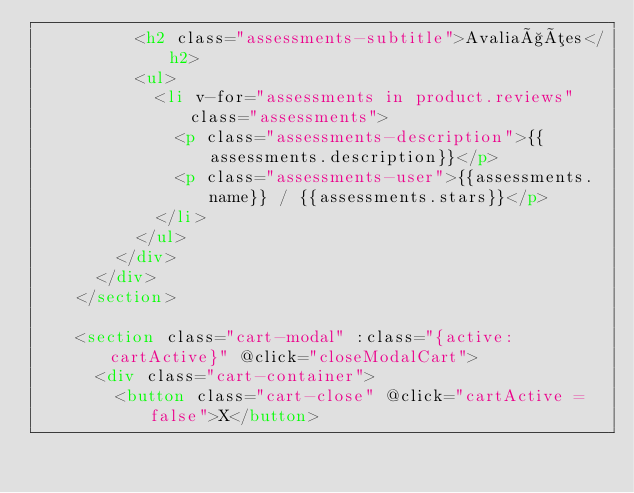<code> <loc_0><loc_0><loc_500><loc_500><_HTML_>          <h2 class="assessments-subtitle">Avaliações</h2>
          <ul>
            <li v-for="assessments in product.reviews" class="assessments">
              <p class="assessments-description">{{assessments.description}}</p>
              <p class="assessments-user">{{assessments.name}} / {{assessments.stars}}</p>
            </li>
          </ul>
        </div>
      </div>
    </section>

    <section class="cart-modal" :class="{active: cartActive}" @click="closeModalCart">
      <div class="cart-container">
        <button class="cart-close" @click="cartActive = false">X</button></code> 